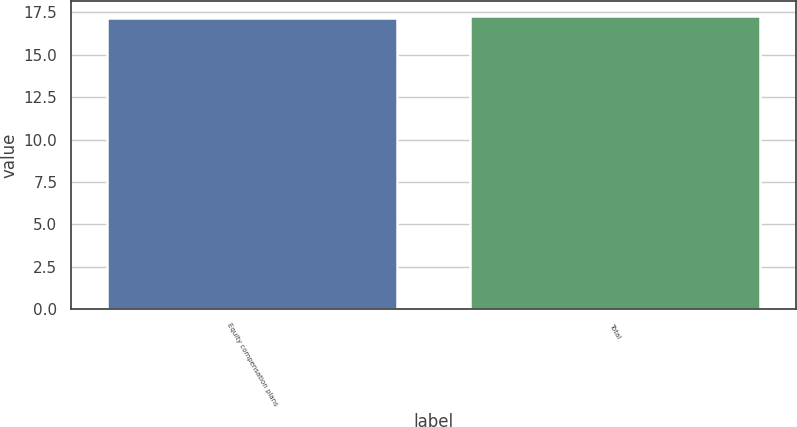Convert chart. <chart><loc_0><loc_0><loc_500><loc_500><bar_chart><fcel>Equity compensation plans<fcel>Total<nl><fcel>17.18<fcel>17.28<nl></chart> 